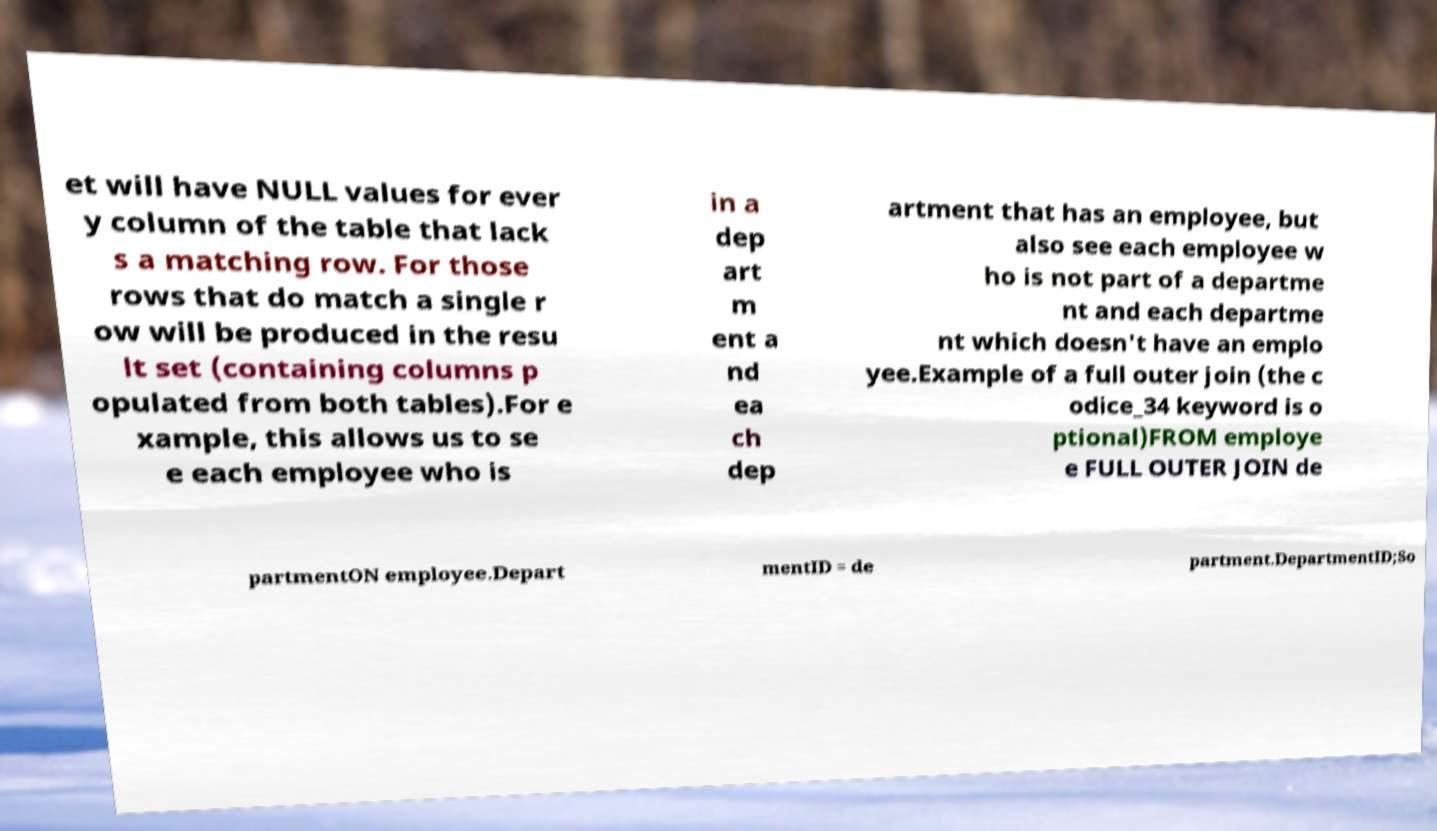Can you read and provide the text displayed in the image?This photo seems to have some interesting text. Can you extract and type it out for me? et will have NULL values for ever y column of the table that lack s a matching row. For those rows that do match a single r ow will be produced in the resu lt set (containing columns p opulated from both tables).For e xample, this allows us to se e each employee who is in a dep art m ent a nd ea ch dep artment that has an employee, but also see each employee w ho is not part of a departme nt and each departme nt which doesn't have an emplo yee.Example of a full outer join (the c odice_34 keyword is o ptional)FROM employe e FULL OUTER JOIN de partmentON employee.Depart mentID = de partment.DepartmentID;So 